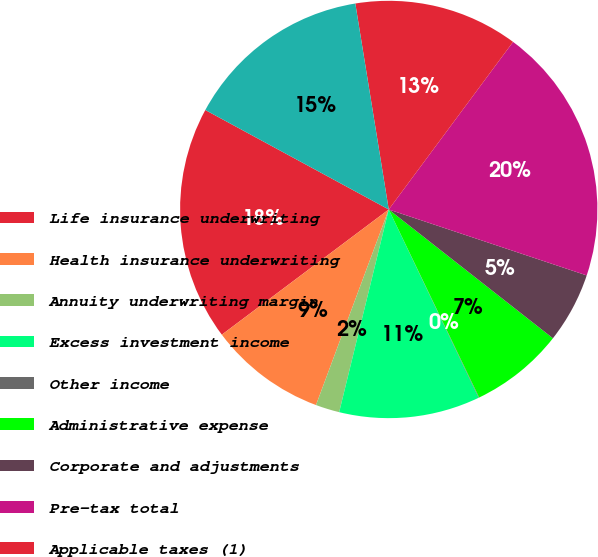<chart> <loc_0><loc_0><loc_500><loc_500><pie_chart><fcel>Life insurance underwriting<fcel>Health insurance underwriting<fcel>Annuity underwriting margin<fcel>Excess investment income<fcel>Other income<fcel>Administrative expense<fcel>Corporate and adjustments<fcel>Pre-tax total<fcel>Applicable taxes (1)<fcel>Net operating income from<nl><fcel>18.15%<fcel>9.09%<fcel>1.85%<fcel>10.91%<fcel>0.04%<fcel>7.28%<fcel>5.47%<fcel>19.96%<fcel>12.72%<fcel>14.53%<nl></chart> 